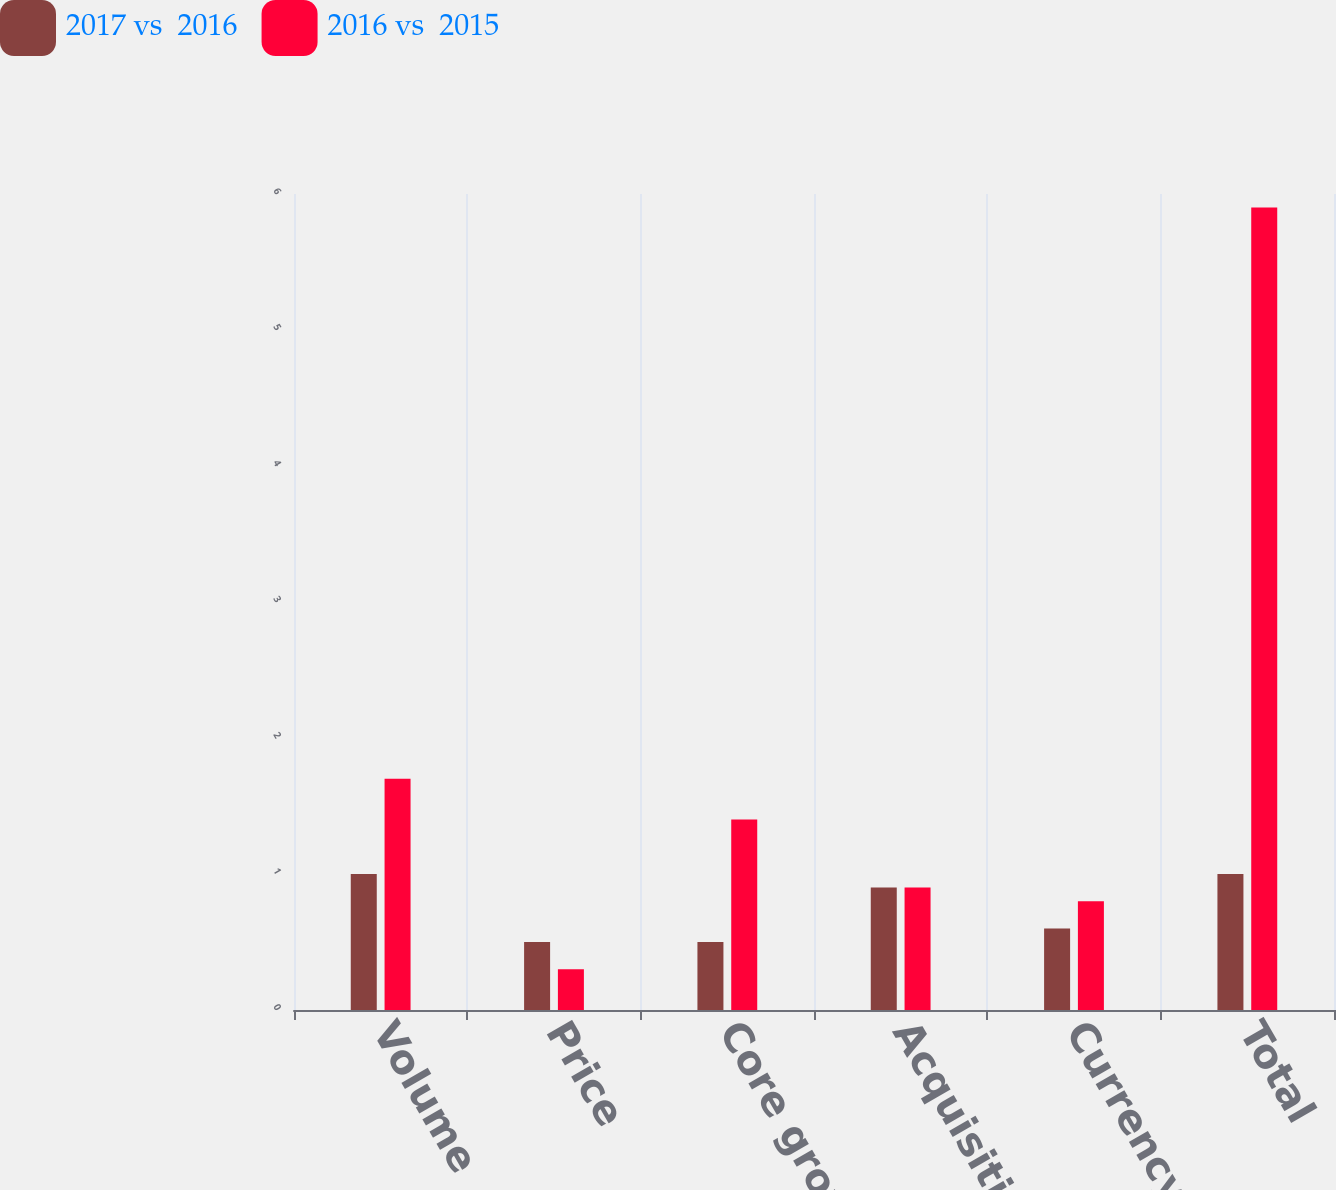Convert chart. <chart><loc_0><loc_0><loc_500><loc_500><stacked_bar_chart><ecel><fcel>Volume<fcel>Price<fcel>Core growth<fcel>Acquisition<fcel>Currency<fcel>Total<nl><fcel>2017 vs  2016<fcel>1<fcel>0.5<fcel>0.5<fcel>0.9<fcel>0.6<fcel>1<nl><fcel>2016 vs  2015<fcel>1.7<fcel>0.3<fcel>1.4<fcel>0.9<fcel>0.8<fcel>5.9<nl></chart> 